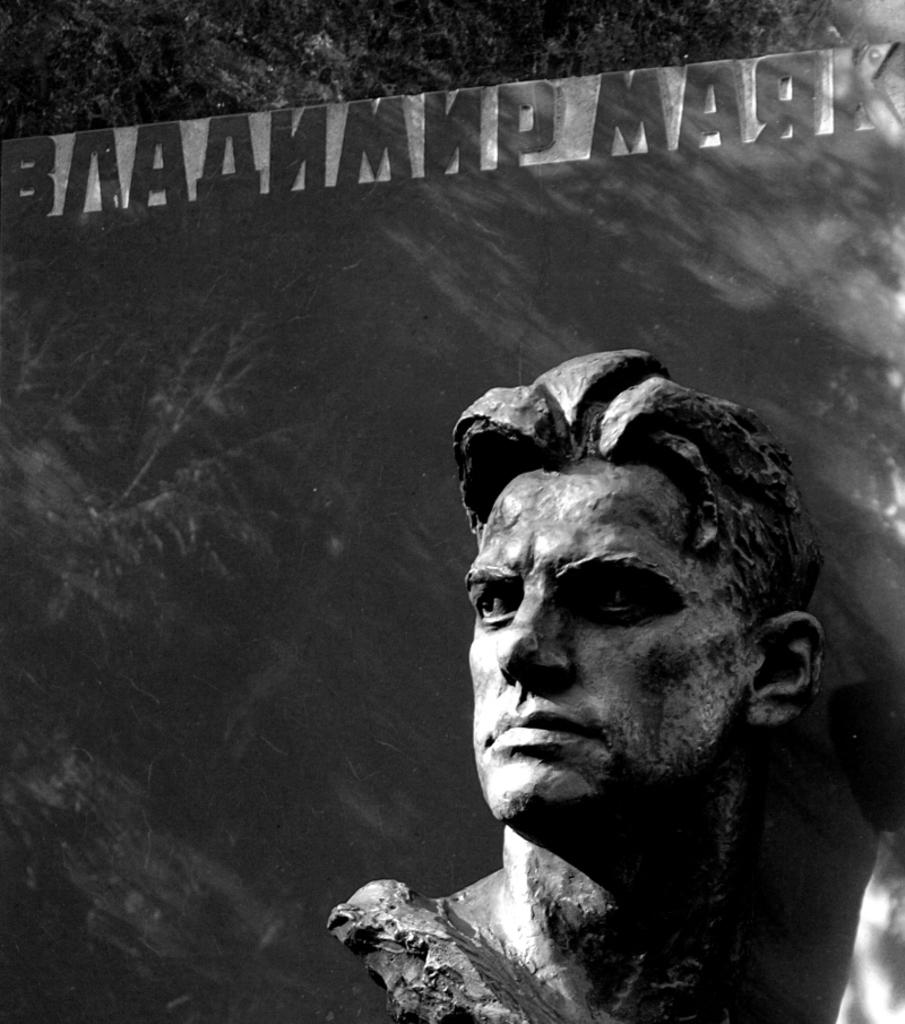What is the main subject in the picture? There is a statue in the picture. What can be seen in the background of the picture? There are trees in the background of the picture. Is there any text present in the image? Yes, there is text at the top of the picture. How many arms are visible on the statue in the image? The provided facts do not mention the number of arms on the statue, so it cannot be determined from the image. 